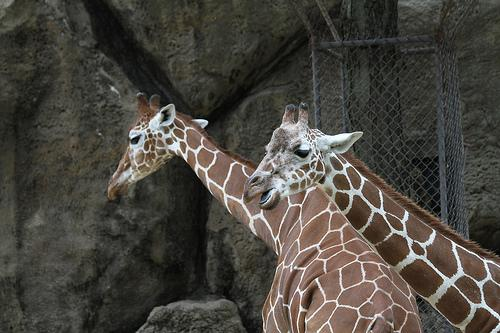Question: how many giraffes are looking at the camera?
Choices:
A. Two.
B. Three.
C. One.
D. Four.
Answer with the letter. Answer: C Question: what type of animals are these?
Choices:
A. Giraffes.
B. Elephants.
C. Dogs.
D. Zebras.
Answer with the letter. Answer: A Question: how many giraffes are there?
Choices:
A. One.
B. Two.
C. Three.
D. Four.
Answer with the letter. Answer: B Question: what is the enclosure made of?
Choices:
A. Rock.
B. Metal.
C. Steel.
D. Plastic.
Answer with the letter. Answer: A Question: what color is the rock?
Choices:
A. Red.
B. Black.
C. Brown.
D. Grey.
Answer with the letter. Answer: D Question: what color are the animals?
Choices:
A. White and black.
B. White and brown.
C. Brown and black.
D. Red and brown.
Answer with the letter. Answer: B 